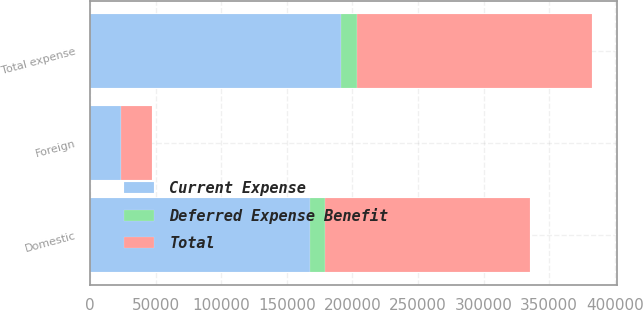Convert chart to OTSL. <chart><loc_0><loc_0><loc_500><loc_500><stacked_bar_chart><ecel><fcel>Domestic<fcel>Foreign<fcel>Total expense<nl><fcel>Total<fcel>156339<fcel>23029<fcel>179368<nl><fcel>Deferred Expense Benefit<fcel>11448<fcel>469<fcel>11917<nl><fcel>Current Expense<fcel>167787<fcel>23498<fcel>191285<nl></chart> 